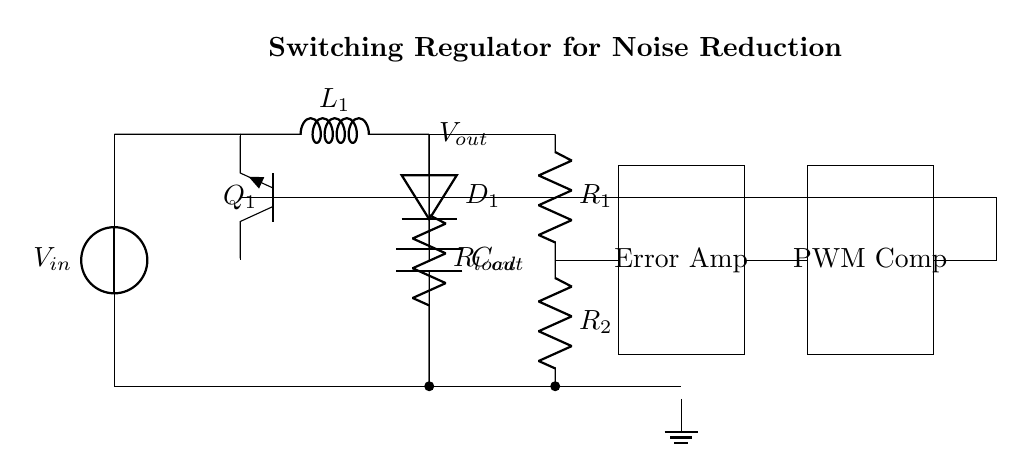What is the input voltage of the circuit? The diagram indicates a voltage source labeled V in at the input, which represents the input voltage for the circuit.
Answer: V in What are the components connected in series with the load? Following the current path from the output towards the load, the output capacitor labeled C out and the resistor labeled R load are in series.
Answer: C out, R load How many resistors are present in the circuit? The circuit shows two resistors labeled R 1 and R 2, both located within the feedback network. Therefore, the total number of resistors is two.
Answer: 2 What is the role of the error amplifier in this circuit? The error amplifier takes the feedback from the output and compares it to a reference voltage, performing regulation by adjusting the PWM comparator's output accordingly.
Answer: Regulation Which component performs the function of switching in this circuit? The variable switching function is performed by the transistor component labeled Q 1, which modulates the voltage and current to the inductor based upon the PWM signal.
Answer: Q 1 What configuration connects the feedback network to the switching transistor? The feedback network is connected to the base of the switching transistor, Q 1, allowing it to adjust its operation based on the output voltage feedback.
Answer: Feedback to Q 1 